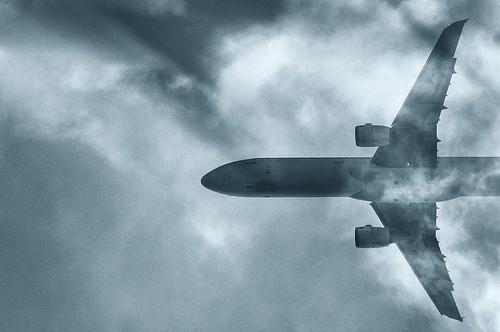How many jets do you see?
Give a very brief answer. 1. 